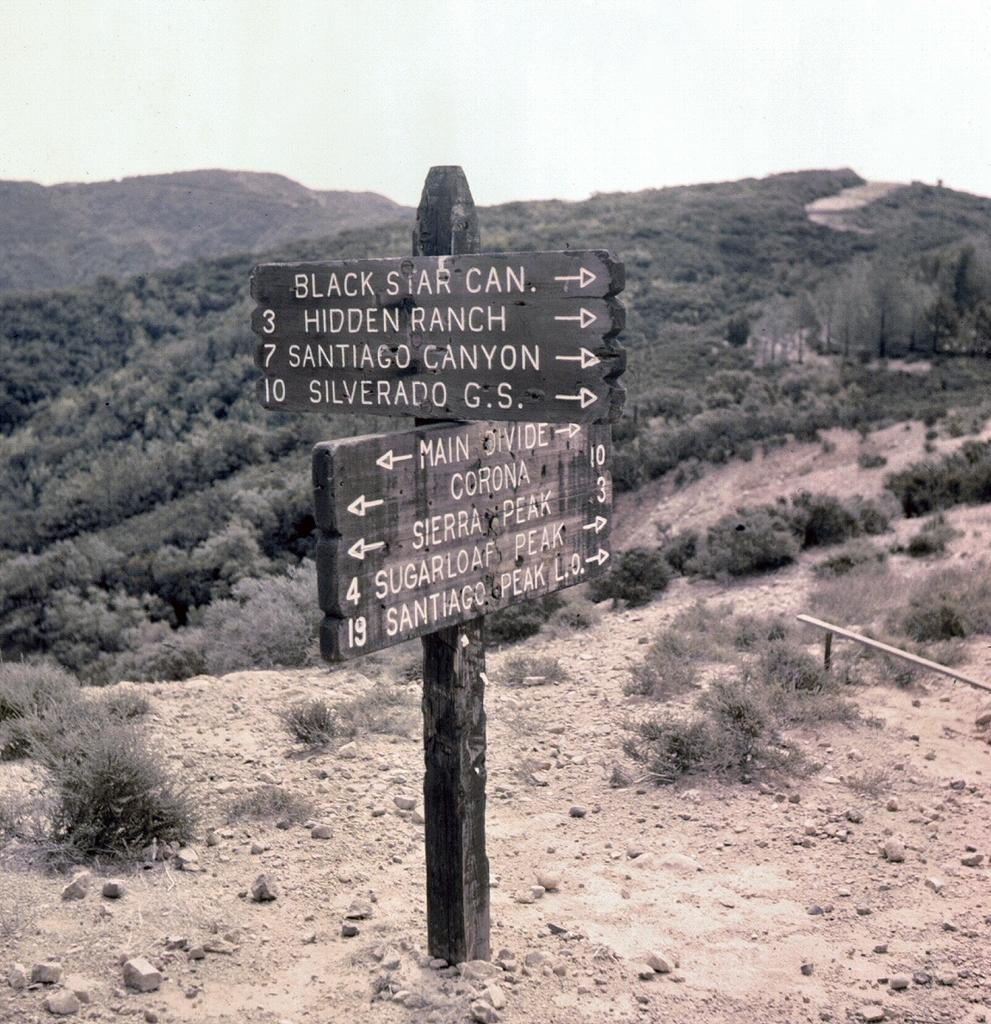What is the main object in the center of the image? There is a board in the center of the image. What can be seen in the background of the image? Hills and the sky are visible in the background of the image. What type of vegetation is present in the image? There are trees present in the image. Where is the girl sitting with a jar of honey in the image? There is no girl or jar of honey present in the image. 